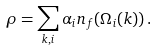Convert formula to latex. <formula><loc_0><loc_0><loc_500><loc_500>\rho = \sum _ { k , i } \alpha _ { i } n _ { f } ( \Omega _ { i } ( k ) ) \, .</formula> 